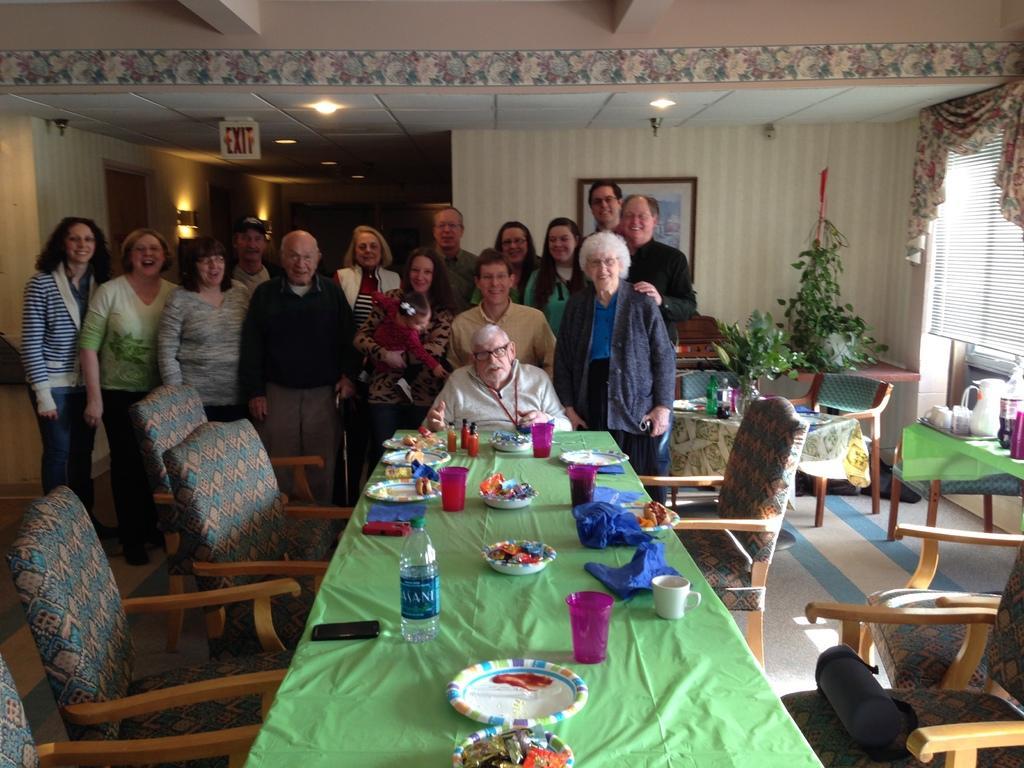In one or two sentences, can you explain what this image depicts? In the picture there are few old man at the back side in front there is dining table with plates and food,it seems to be in a dining room. 